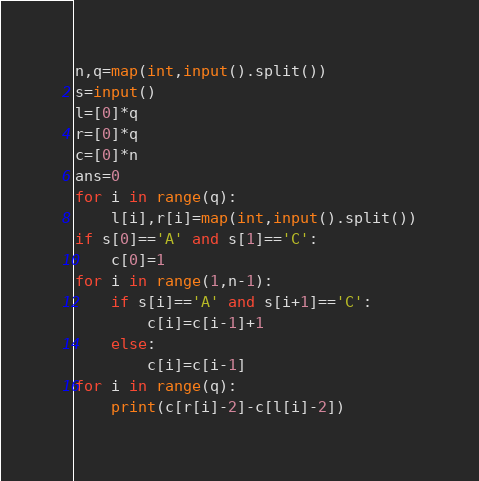<code> <loc_0><loc_0><loc_500><loc_500><_Python_>n,q=map(int,input().split())
s=input()
l=[0]*q
r=[0]*q
c=[0]*n
ans=0
for i in range(q):
    l[i],r[i]=map(int,input().split())
if s[0]=='A' and s[1]=='C':
    c[0]=1
for i in range(1,n-1):
    if s[i]=='A' and s[i+1]=='C':
        c[i]=c[i-1]+1
    else:
        c[i]=c[i-1]
for i in range(q):
    print(c[r[i]-2]-c[l[i]-2])</code> 